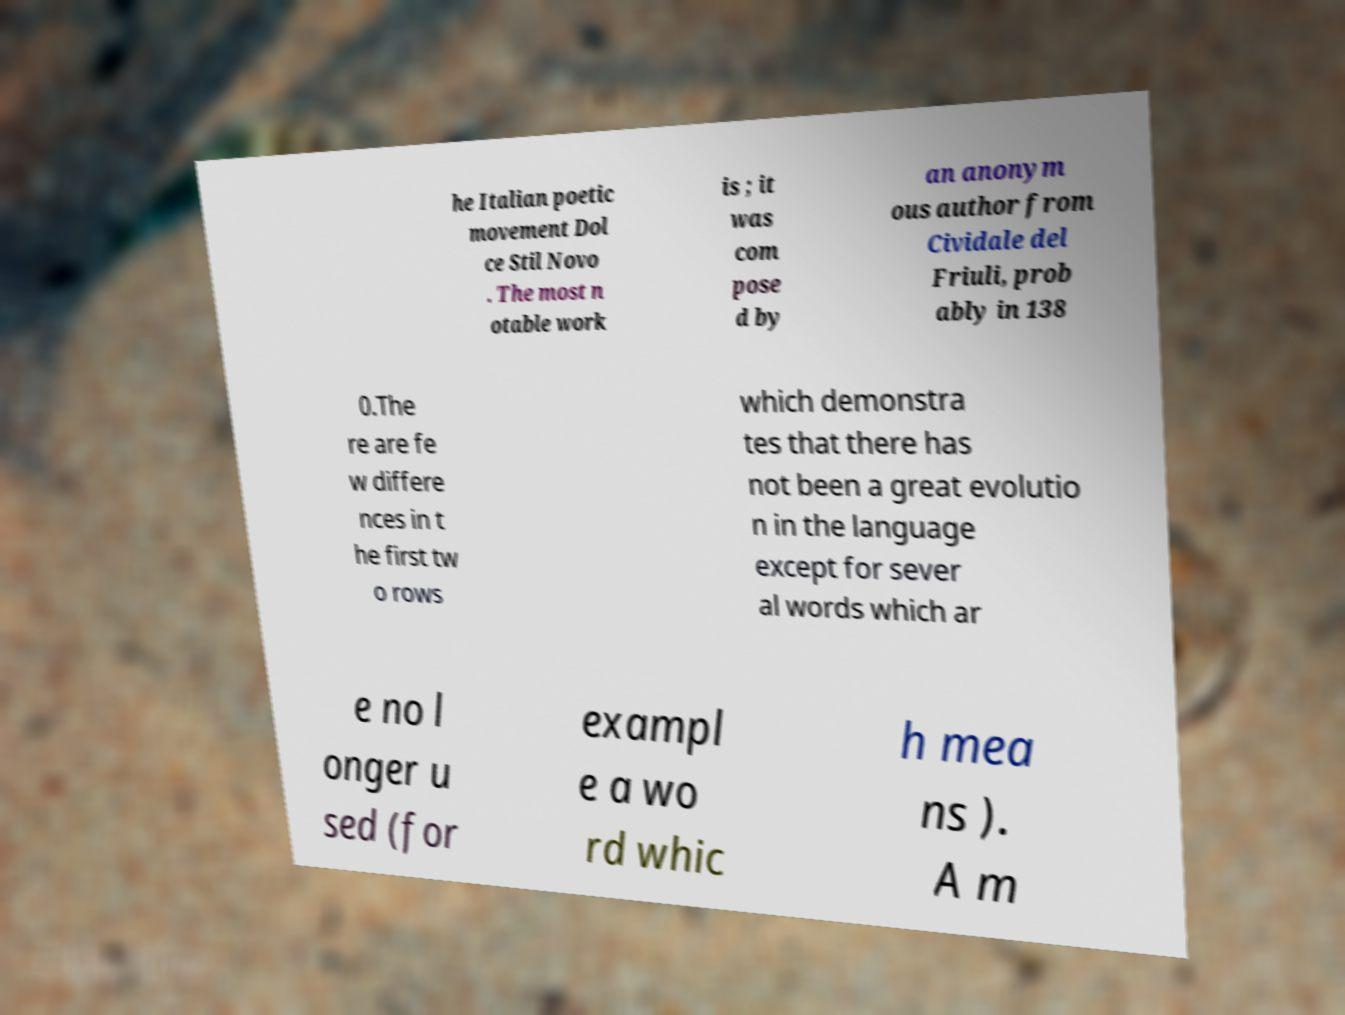Could you extract and type out the text from this image? he Italian poetic movement Dol ce Stil Novo . The most n otable work is ; it was com pose d by an anonym ous author from Cividale del Friuli, prob ably in 138 0.The re are fe w differe nces in t he first tw o rows which demonstra tes that there has not been a great evolutio n in the language except for sever al words which ar e no l onger u sed (for exampl e a wo rd whic h mea ns ). A m 